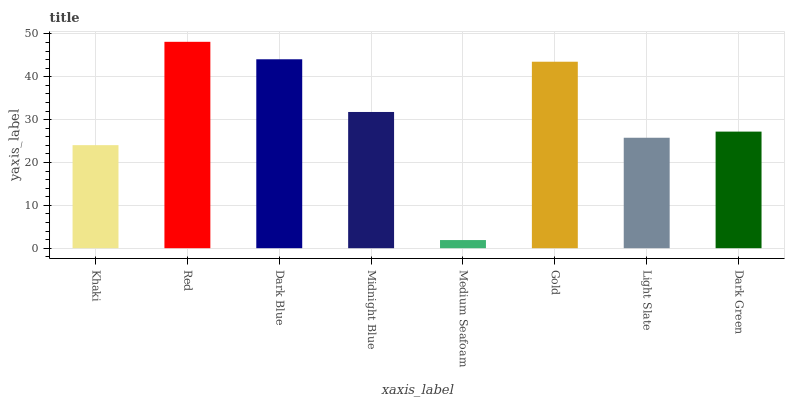Is Dark Blue the minimum?
Answer yes or no. No. Is Dark Blue the maximum?
Answer yes or no. No. Is Red greater than Dark Blue?
Answer yes or no. Yes. Is Dark Blue less than Red?
Answer yes or no. Yes. Is Dark Blue greater than Red?
Answer yes or no. No. Is Red less than Dark Blue?
Answer yes or no. No. Is Midnight Blue the high median?
Answer yes or no. Yes. Is Dark Green the low median?
Answer yes or no. Yes. Is Light Slate the high median?
Answer yes or no. No. Is Midnight Blue the low median?
Answer yes or no. No. 